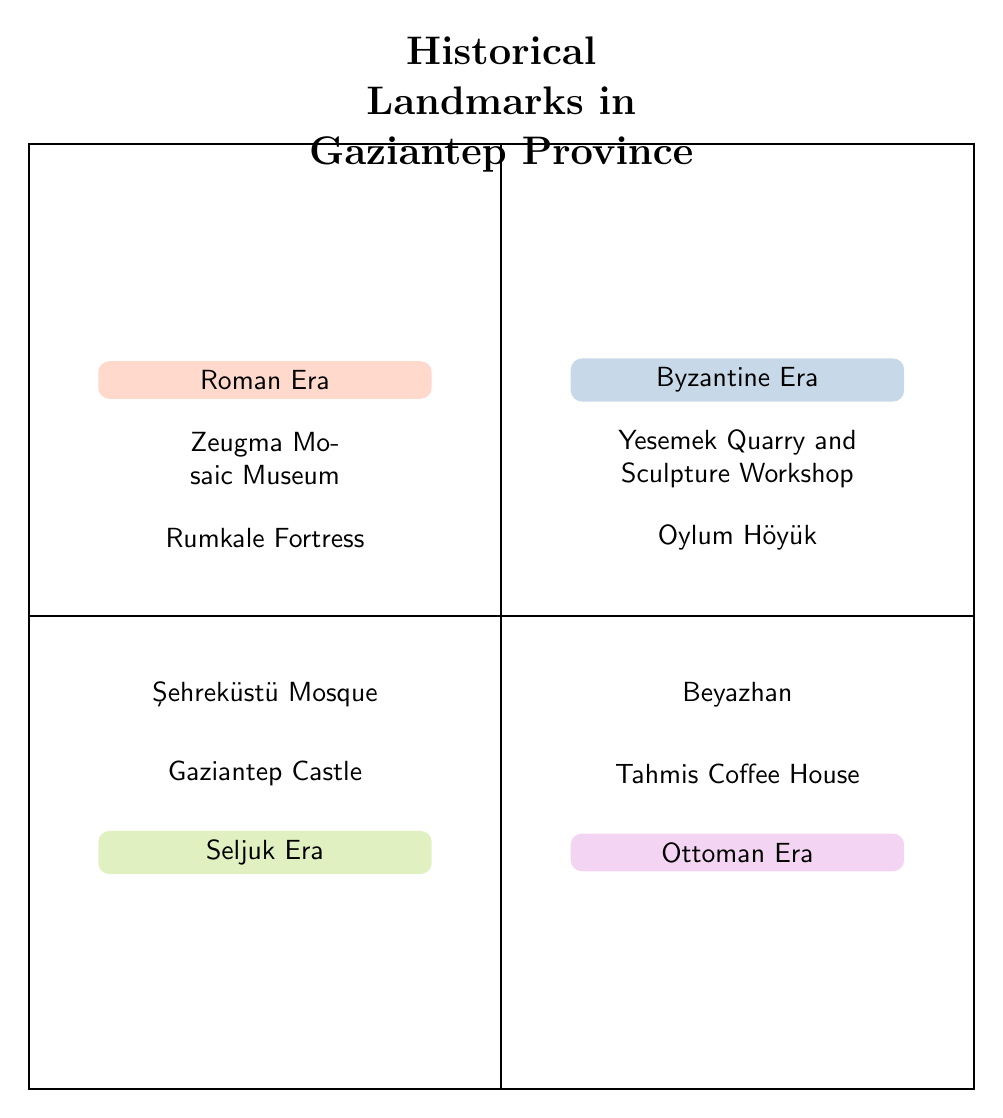What are the two landmarks in the Roman Era quadrant? The Roman Era quadrant lists two landmarks: the Zeugma Mosaic Museum and the Rumkale Fortress.
Answer: Zeugma Mosaic Museum, Rumkale Fortress How many landmarks are associated with the Byzantine Era? The Byzantine Era quadrant contains two landmarks: Yesemek Quarry and Sculpture Workshop and Oylum Höyük. Thus, the total is two.
Answer: 2 Which era contains Gaziantep Castle? Gaziantep Castle is located in the Seljuk Era quadrant, as indicated in that section of the diagram.
Answer: Seljuk Era List one landmark from the Ottoman Era. The Ottoman Era quadrant features two landmarks, one of which is the Tahmis Coffee House. Therefore, a single landmark from this era is the Tahmis Coffee House.
Answer: Tahmis Coffee House Which two eras are adjacent in this diagram? The Roman Era and Byzantine Era quadrants are adjacent on the upper side of the diagram, while the Seljuk Era and Ottoman Era are adjacent on the lower side.
Answer: Roman Era, Byzantine Era How many eras are represented in the chart? The diagram contains four quadrants, each representing a different historical era: Roman, Byzantine, Seljuk, and Ottoman. Thus, the total number of eras is four.
Answer: 4 What is the relationship between the Byzantine Era and Seljuk Era in terms of landmark quantity? Both the Byzantine Era and Seljuk Era quadrants have two landmarks each, indicating an equal quantity of preserved historical landmarks.
Answer: Equal What colors represent the Ottoman Era? The Ottoman Era quadrant is filled with a distinct color that is labeled as rose or mauve, separate from the other quadrants in the diagram.
Answer: Rose or mauve Which landmark belongs to the Byzantine Era? The Yesemek Quarry and Sculpture Workshop is listed under the Byzantine Era quadrant, representing this historical period within Gaziantep.
Answer: Yesemek Quarry and Sculpture Workshop 